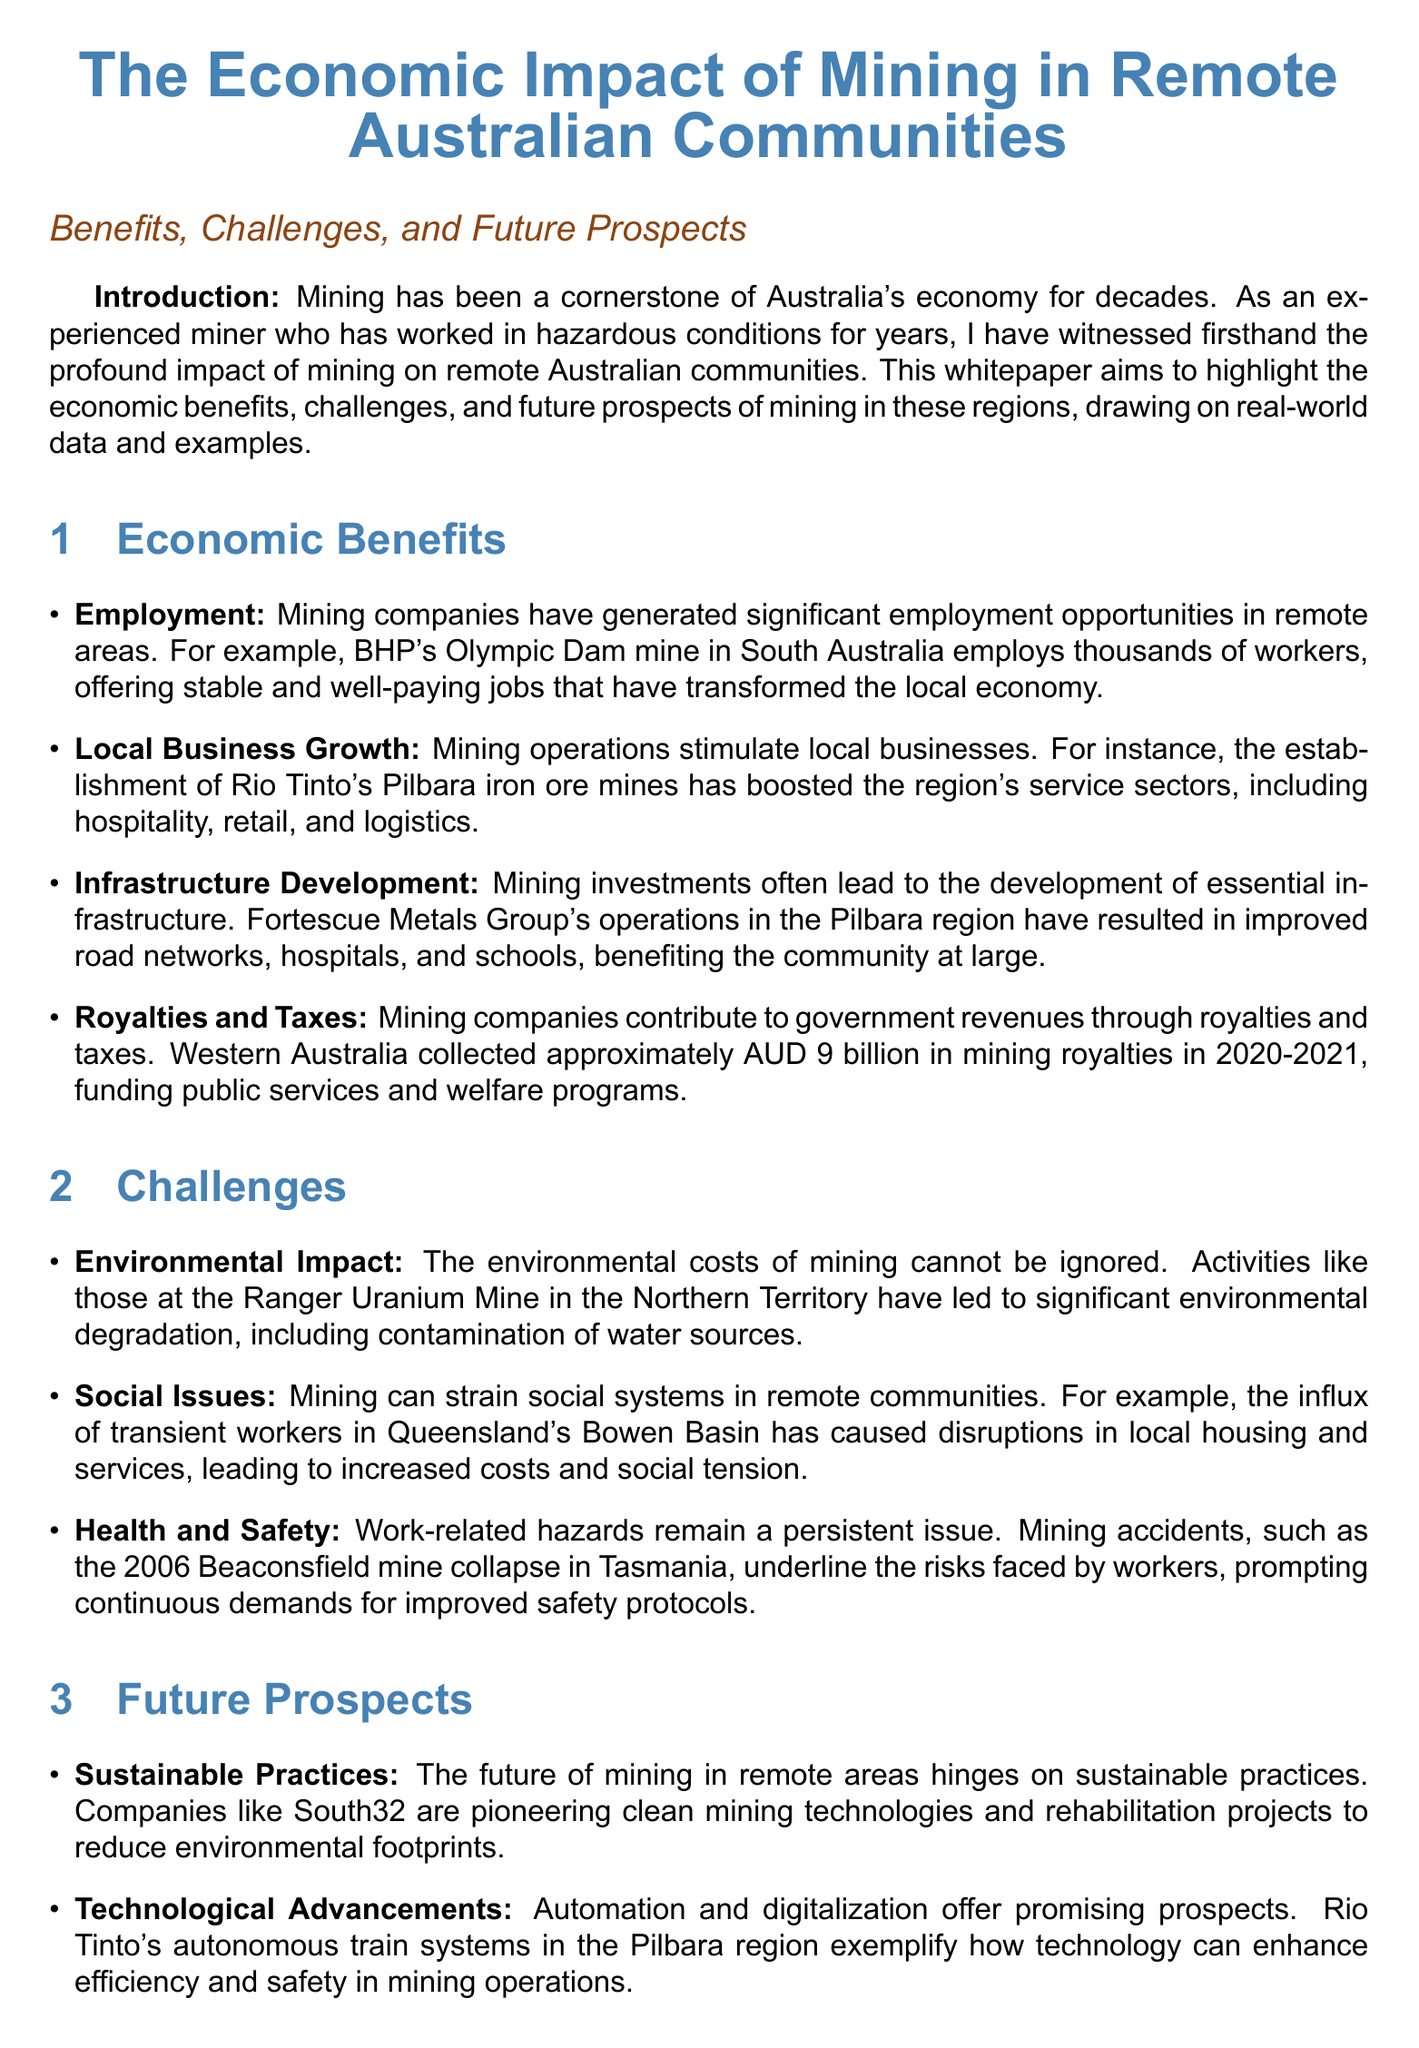What mining company employs thousands at Olympic Dam? The document mentions BHP's Olympic Dam mine in South Australia as a significant employer in the region.
Answer: BHP How much did Western Australia collect in mining royalties in 2020-2021? The whitepaper states that Western Australia collected approximately AUD 9 billion in mining royalties.
Answer: AUD 9 billion What is a key environmental concern mentioned in the document? The document discusses the environmental degradation caused by mining, particularly contamination of water sources, as highlighted by the Ranger Uranium Mine example.
Answer: Environmental degradation Which company is pioneering clean mining technologies? The document cites South32 as a company that is pioneering clean mining technologies and rehabilitation projects to reduce environmental footprints.
Answer: South32 What social issue has arisen from mining in Queensland's Bowen Basin? The influx of transient workers leading to disruptions in local housing and services is mentioned as a social issue caused by mining in this region.
Answer: Disruptions in local housing What does the document suggest is essential for the future of mining? The document emphasizes the importance of sustainable practices for the future of mining in remote areas.
Answer: Sustainable practices Which company's autonomous train systems exemplify technological advancements? The document references Rio Tinto's autonomous train systems in the Pilbara region as an example of technological advancements in mining.
Answer: Rio Tinto What is highlighted as a best practice for community relations? The importance of community engagement and involving local Indigenous groups in decision-making is emphasized as a best practice.
Answer: Community engagement What incident underscores the need for improved safety protocols? The document references the 2006 Beaconsfield mine collapse as an incident that highlights the need for better safety protocols in mining.
Answer: Beaconsfield mine collapse 